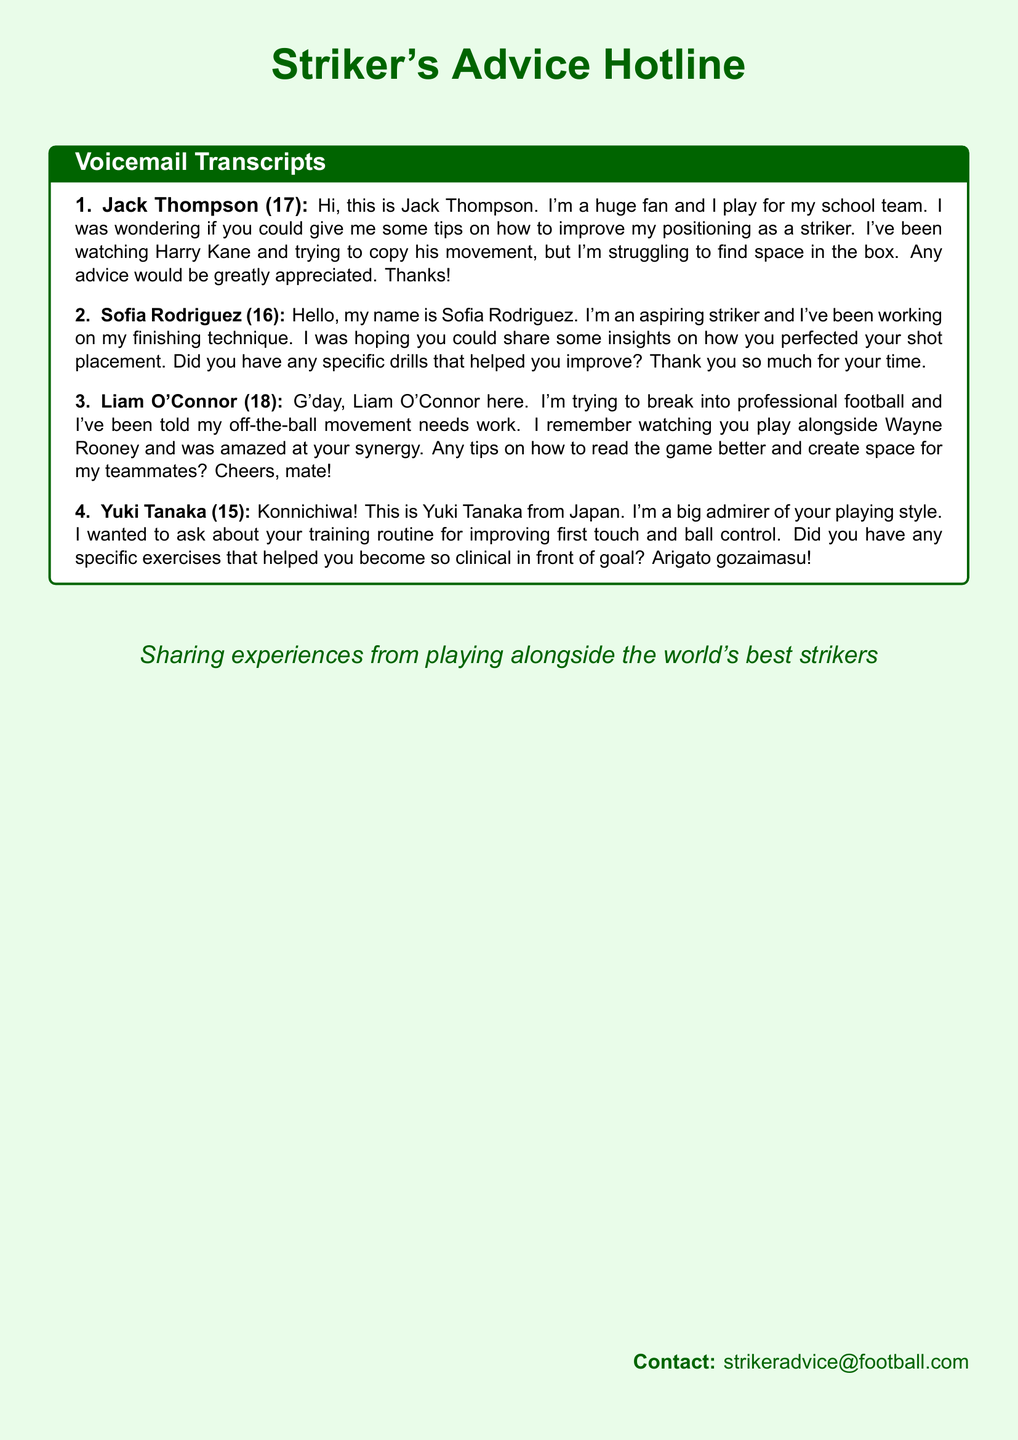What is the name of the first caller? The name of the first caller is stated in the document as Jack Thompson.
Answer: Jack Thompson How old is Sofia Rodriguez? Sofia Rodriguez's age is specified in the message as 16.
Answer: 16 Which striker does Jack Thompson mention in his voicemail? Jack Thompson mentions Harry Kane as the striker he is watching for movement tips.
Answer: Harry Kane What specific technique does Liam O'Connor want to improve? Liam O'Connor mentions he needs to work on his off-the-ball movement.
Answer: Off-the-ball movement What nationality is Yuki Tanaka? Yuki Tanaka identifies himself as being from Japan in his voicemail.
Answer: Japan Which legendary player did the respondent play alongside? The voicemail from Liam O'Connor references playing alongside Wayne Rooney.
Answer: Wayne Rooney What is the contact email for further advice? The document lists the contact email for striker advice as strikeradvice@football.com.
Answer: strikeradvice@football.com How does Yuki Tanaka refer to the respondent in his voicemail? Yuki Tanaka uses "Konnichiwa!" and "Arigato gozaimasu!" indicating respect and admiration.
Answer: Konnichiwa and Arigato gozaimasu What kind of advice do the young footballers seek? The young footballers are seeking advice on striker positioning and technique.
Answer: Striker positioning and technique 